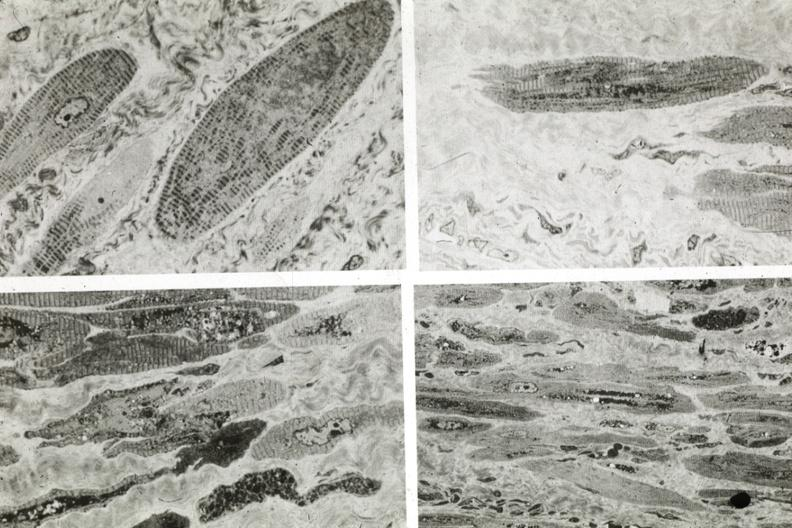what does this image show?
Answer the question using a single word or phrase. Marked fiber atrophy 